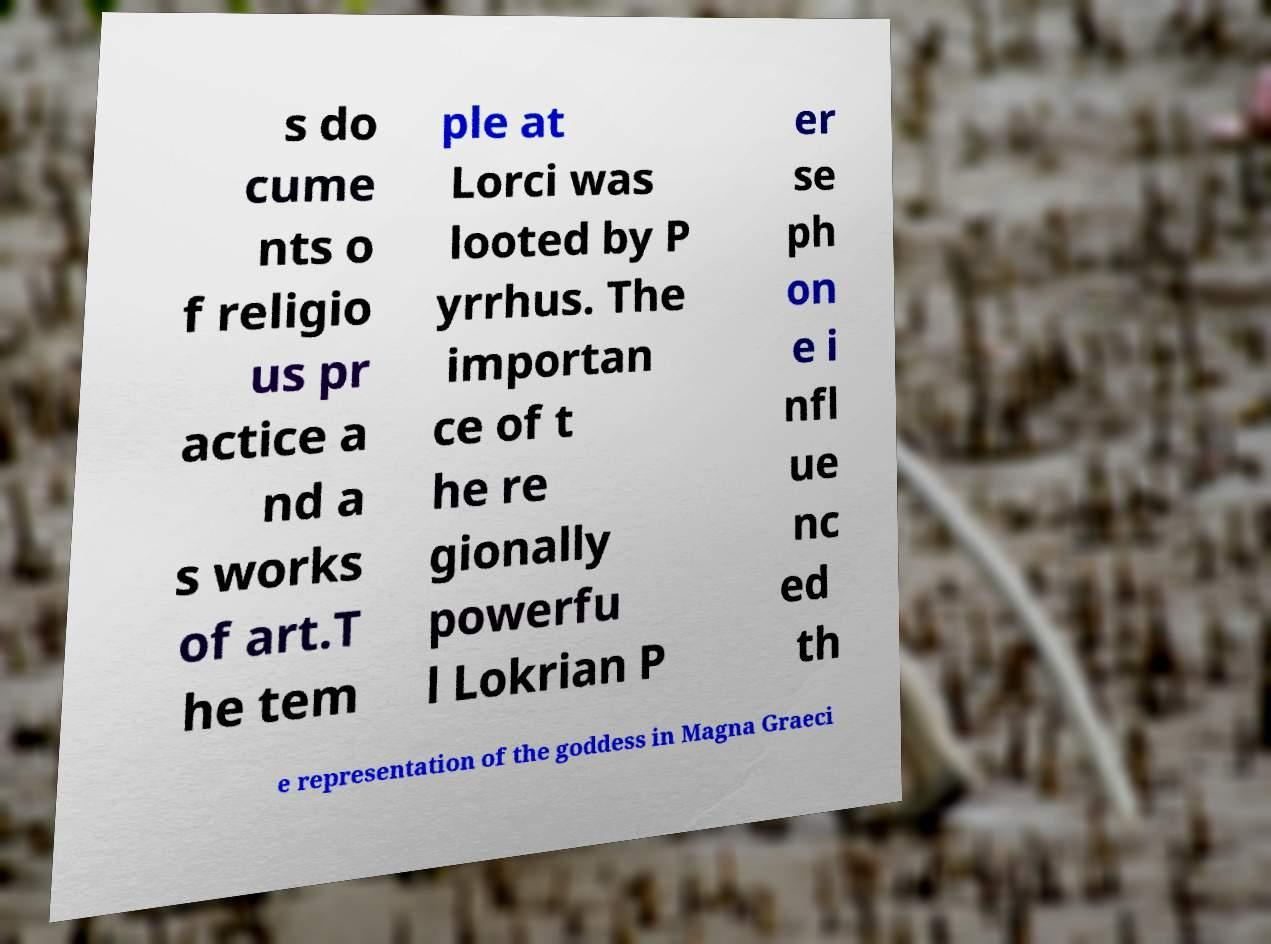Can you read and provide the text displayed in the image?This photo seems to have some interesting text. Can you extract and type it out for me? s do cume nts o f religio us pr actice a nd a s works of art.T he tem ple at Lorci was looted by P yrrhus. The importan ce of t he re gionally powerfu l Lokrian P er se ph on e i nfl ue nc ed th e representation of the goddess in Magna Graeci 